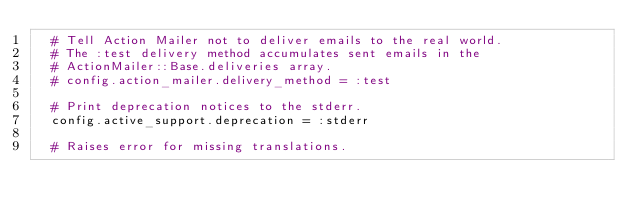<code> <loc_0><loc_0><loc_500><loc_500><_Ruby_>  # Tell Action Mailer not to deliver emails to the real world.
  # The :test delivery method accumulates sent emails in the
  # ActionMailer::Base.deliveries array.
  # config.action_mailer.delivery_method = :test

  # Print deprecation notices to the stderr.
  config.active_support.deprecation = :stderr

  # Raises error for missing translations.</code> 